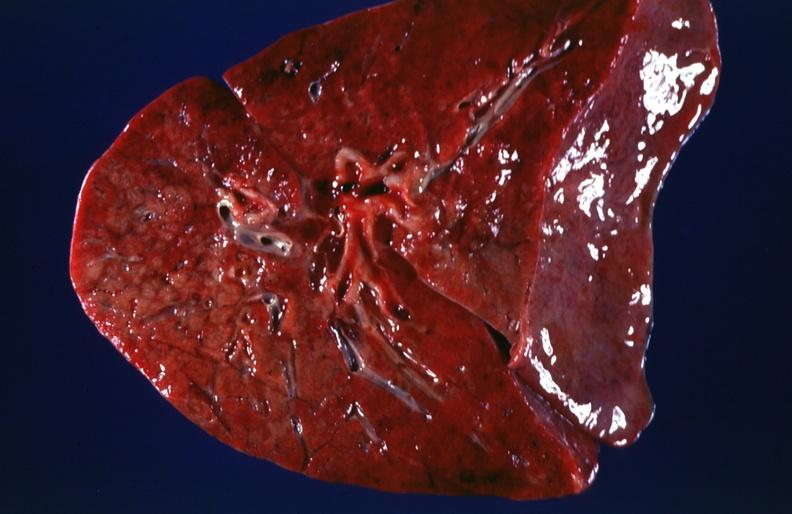s respiratory present?
Answer the question using a single word or phrase. Yes 